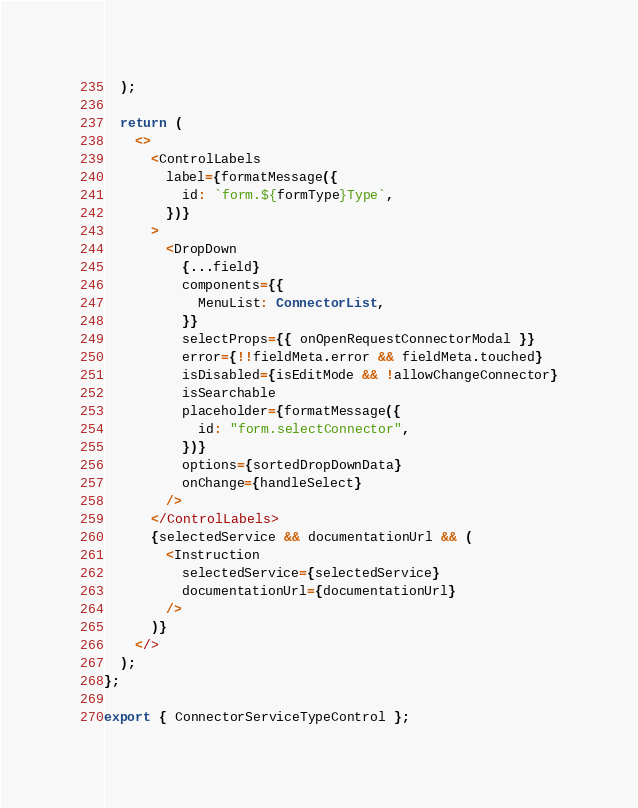Convert code to text. <code><loc_0><loc_0><loc_500><loc_500><_TypeScript_>  );

  return (
    <>
      <ControlLabels
        label={formatMessage({
          id: `form.${formType}Type`,
        })}
      >
        <DropDown
          {...field}
          components={{
            MenuList: ConnectorList,
          }}
          selectProps={{ onOpenRequestConnectorModal }}
          error={!!fieldMeta.error && fieldMeta.touched}
          isDisabled={isEditMode && !allowChangeConnector}
          isSearchable
          placeholder={formatMessage({
            id: "form.selectConnector",
          })}
          options={sortedDropDownData}
          onChange={handleSelect}
        />
      </ControlLabels>
      {selectedService && documentationUrl && (
        <Instruction
          selectedService={selectedService}
          documentationUrl={documentationUrl}
        />
      )}
    </>
  );
};

export { ConnectorServiceTypeControl };
</code> 